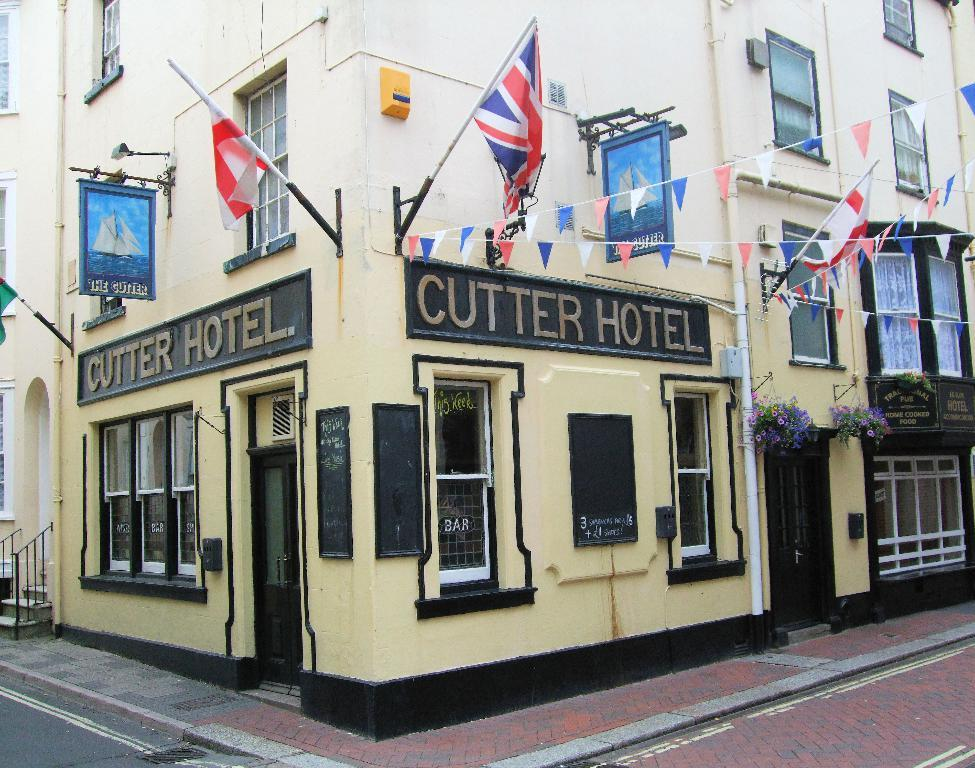What type of structure is depicted in the image? The image is of a building. What can be seen on the building's exterior? There are boards, flags, hoardings, plants, and windows on the building. What type of produce is being taught in the building? There is no indication of any teaching or produce in the image, as it only shows a building with various elements on its exterior. 